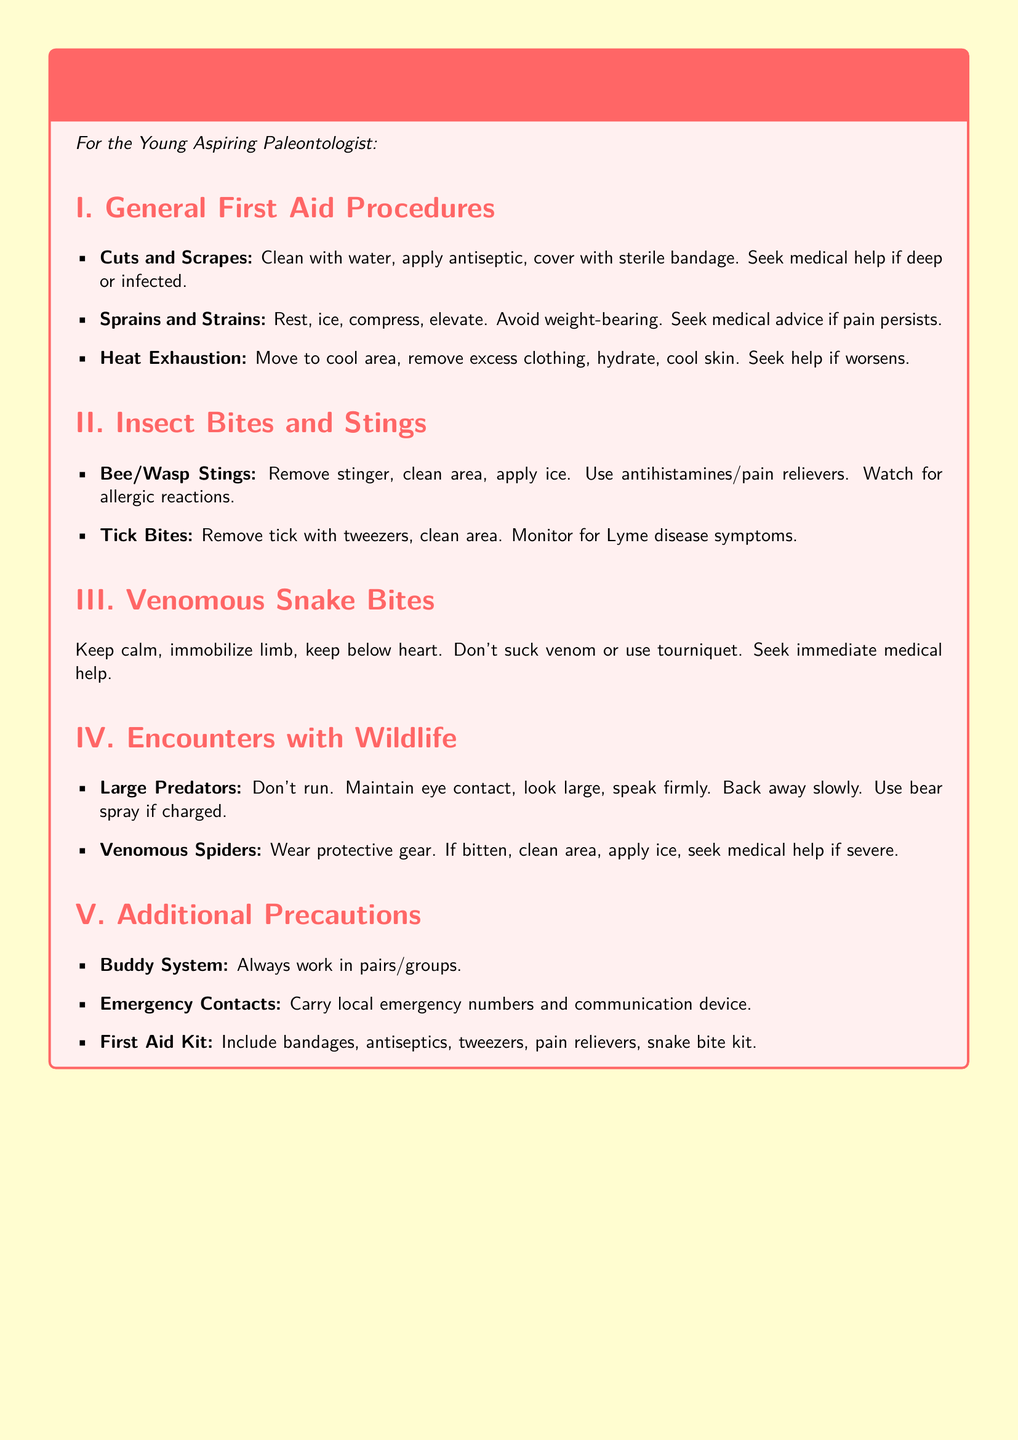What should you do for cuts and scrapes? The document states to clean with water, apply antiseptic, and cover with a sterile bandage.
Answer: Clean with water, apply antiseptic, cover with sterile bandage What is the first step for heat exhaustion? The first step mentioned is to move to a cool area.
Answer: Move to cool area What is advised if you get a bee or wasp sting? The document advises to remove the stinger, clean the area, and apply ice.
Answer: Remove stinger, clean area, apply ice What should you do if bitten by a venomous spider? The document states to clean the area, apply ice, and seek medical help if severe.
Answer: Clean area, apply ice, seek medical help if severe How should you respond to a large predator encounter? The document advises not to run, maintain eye contact, and back away slowly.
Answer: Don't run, maintain eye contact, back away slowly What item is essential in the first aid kit? A snake bite kit is one of the essential items listed in the first aid kit.
Answer: Snake bite kit What is emphasized in terms of safety method? The buddy system is emphasized for safety during fieldwork.
Answer: Buddy system How should you remove a tick? You should remove it with tweezers as stated in the document.
Answer: With tweezers 